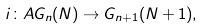Convert formula to latex. <formula><loc_0><loc_0><loc_500><loc_500>i \colon A G _ { n } ( N ) \to G _ { n + 1 } ( N + 1 ) ,</formula> 